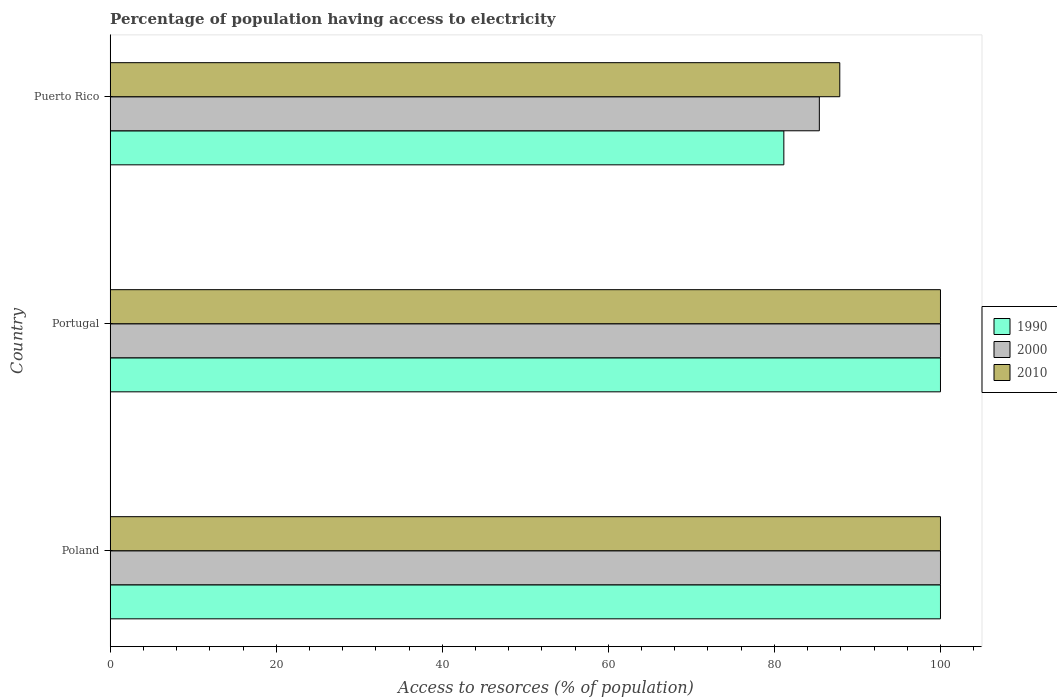How many groups of bars are there?
Provide a short and direct response. 3. Are the number of bars per tick equal to the number of legend labels?
Your answer should be compact. Yes. Are the number of bars on each tick of the Y-axis equal?
Provide a succinct answer. Yes. How many bars are there on the 1st tick from the bottom?
Your response must be concise. 3. What is the label of the 1st group of bars from the top?
Make the answer very short. Puerto Rico. Across all countries, what is the minimum percentage of population having access to electricity in 1990?
Your answer should be very brief. 81.14. In which country was the percentage of population having access to electricity in 2000 minimum?
Keep it short and to the point. Puerto Rico. What is the total percentage of population having access to electricity in 2010 in the graph?
Offer a terse response. 287.87. What is the difference between the percentage of population having access to electricity in 2000 in Portugal and that in Puerto Rico?
Ensure brevity in your answer.  14.59. What is the difference between the percentage of population having access to electricity in 1990 in Poland and the percentage of population having access to electricity in 2000 in Puerto Rico?
Offer a very short reply. 14.59. What is the average percentage of population having access to electricity in 1990 per country?
Your answer should be compact. 93.71. What is the difference between the percentage of population having access to electricity in 2010 and percentage of population having access to electricity in 2000 in Portugal?
Keep it short and to the point. 0. In how many countries, is the percentage of population having access to electricity in 2010 greater than 4 %?
Make the answer very short. 3. What is the ratio of the percentage of population having access to electricity in 1990 in Portugal to that in Puerto Rico?
Keep it short and to the point. 1.23. What is the difference between the highest and the second highest percentage of population having access to electricity in 1990?
Ensure brevity in your answer.  0. What is the difference between the highest and the lowest percentage of population having access to electricity in 2000?
Give a very brief answer. 14.59. In how many countries, is the percentage of population having access to electricity in 2000 greater than the average percentage of population having access to electricity in 2000 taken over all countries?
Your answer should be compact. 2. How many bars are there?
Give a very brief answer. 9. Are all the bars in the graph horizontal?
Keep it short and to the point. Yes. How many countries are there in the graph?
Provide a short and direct response. 3. Does the graph contain any zero values?
Keep it short and to the point. No. Where does the legend appear in the graph?
Offer a terse response. Center right. How many legend labels are there?
Offer a terse response. 3. How are the legend labels stacked?
Your answer should be compact. Vertical. What is the title of the graph?
Your answer should be compact. Percentage of population having access to electricity. Does "1998" appear as one of the legend labels in the graph?
Provide a short and direct response. No. What is the label or title of the X-axis?
Offer a terse response. Access to resorces (% of population). What is the Access to resorces (% of population) of 1990 in Poland?
Your response must be concise. 100. What is the Access to resorces (% of population) of 2010 in Poland?
Your response must be concise. 100. What is the Access to resorces (% of population) in 1990 in Portugal?
Your answer should be very brief. 100. What is the Access to resorces (% of population) in 2010 in Portugal?
Make the answer very short. 100. What is the Access to resorces (% of population) in 1990 in Puerto Rico?
Offer a terse response. 81.14. What is the Access to resorces (% of population) in 2000 in Puerto Rico?
Offer a terse response. 85.41. What is the Access to resorces (% of population) in 2010 in Puerto Rico?
Provide a short and direct response. 87.87. Across all countries, what is the maximum Access to resorces (% of population) of 2000?
Your response must be concise. 100. Across all countries, what is the minimum Access to resorces (% of population) in 1990?
Your answer should be very brief. 81.14. Across all countries, what is the minimum Access to resorces (% of population) in 2000?
Give a very brief answer. 85.41. Across all countries, what is the minimum Access to resorces (% of population) in 2010?
Offer a very short reply. 87.87. What is the total Access to resorces (% of population) of 1990 in the graph?
Your answer should be very brief. 281.14. What is the total Access to resorces (% of population) in 2000 in the graph?
Provide a succinct answer. 285.41. What is the total Access to resorces (% of population) of 2010 in the graph?
Give a very brief answer. 287.87. What is the difference between the Access to resorces (% of population) of 1990 in Poland and that in Portugal?
Your response must be concise. 0. What is the difference between the Access to resorces (% of population) of 2000 in Poland and that in Portugal?
Ensure brevity in your answer.  0. What is the difference between the Access to resorces (% of population) of 1990 in Poland and that in Puerto Rico?
Your answer should be very brief. 18.86. What is the difference between the Access to resorces (% of population) of 2000 in Poland and that in Puerto Rico?
Your answer should be very brief. 14.59. What is the difference between the Access to resorces (% of population) of 2010 in Poland and that in Puerto Rico?
Ensure brevity in your answer.  12.13. What is the difference between the Access to resorces (% of population) of 1990 in Portugal and that in Puerto Rico?
Your response must be concise. 18.86. What is the difference between the Access to resorces (% of population) of 2000 in Portugal and that in Puerto Rico?
Your answer should be compact. 14.59. What is the difference between the Access to resorces (% of population) in 2010 in Portugal and that in Puerto Rico?
Provide a succinct answer. 12.13. What is the difference between the Access to resorces (% of population) in 2000 in Poland and the Access to resorces (% of population) in 2010 in Portugal?
Your response must be concise. 0. What is the difference between the Access to resorces (% of population) of 1990 in Poland and the Access to resorces (% of population) of 2000 in Puerto Rico?
Ensure brevity in your answer.  14.59. What is the difference between the Access to resorces (% of population) of 1990 in Poland and the Access to resorces (% of population) of 2010 in Puerto Rico?
Provide a short and direct response. 12.13. What is the difference between the Access to resorces (% of population) of 2000 in Poland and the Access to resorces (% of population) of 2010 in Puerto Rico?
Give a very brief answer. 12.13. What is the difference between the Access to resorces (% of population) in 1990 in Portugal and the Access to resorces (% of population) in 2000 in Puerto Rico?
Offer a very short reply. 14.59. What is the difference between the Access to resorces (% of population) of 1990 in Portugal and the Access to resorces (% of population) of 2010 in Puerto Rico?
Ensure brevity in your answer.  12.13. What is the difference between the Access to resorces (% of population) in 2000 in Portugal and the Access to resorces (% of population) in 2010 in Puerto Rico?
Your answer should be very brief. 12.13. What is the average Access to resorces (% of population) in 1990 per country?
Your answer should be very brief. 93.71. What is the average Access to resorces (% of population) of 2000 per country?
Keep it short and to the point. 95.14. What is the average Access to resorces (% of population) in 2010 per country?
Keep it short and to the point. 95.96. What is the difference between the Access to resorces (% of population) in 2000 and Access to resorces (% of population) in 2010 in Poland?
Provide a short and direct response. 0. What is the difference between the Access to resorces (% of population) of 1990 and Access to resorces (% of population) of 2000 in Portugal?
Offer a terse response. 0. What is the difference between the Access to resorces (% of population) of 2000 and Access to resorces (% of population) of 2010 in Portugal?
Keep it short and to the point. 0. What is the difference between the Access to resorces (% of population) of 1990 and Access to resorces (% of population) of 2000 in Puerto Rico?
Offer a terse response. -4.28. What is the difference between the Access to resorces (% of population) of 1990 and Access to resorces (% of population) of 2010 in Puerto Rico?
Offer a very short reply. -6.74. What is the difference between the Access to resorces (% of population) of 2000 and Access to resorces (% of population) of 2010 in Puerto Rico?
Provide a succinct answer. -2.46. What is the ratio of the Access to resorces (% of population) in 1990 in Poland to that in Portugal?
Offer a very short reply. 1. What is the ratio of the Access to resorces (% of population) of 2000 in Poland to that in Portugal?
Your answer should be very brief. 1. What is the ratio of the Access to resorces (% of population) in 2010 in Poland to that in Portugal?
Your answer should be compact. 1. What is the ratio of the Access to resorces (% of population) in 1990 in Poland to that in Puerto Rico?
Make the answer very short. 1.23. What is the ratio of the Access to resorces (% of population) in 2000 in Poland to that in Puerto Rico?
Provide a short and direct response. 1.17. What is the ratio of the Access to resorces (% of population) of 2010 in Poland to that in Puerto Rico?
Your answer should be compact. 1.14. What is the ratio of the Access to resorces (% of population) in 1990 in Portugal to that in Puerto Rico?
Offer a very short reply. 1.23. What is the ratio of the Access to resorces (% of population) in 2000 in Portugal to that in Puerto Rico?
Keep it short and to the point. 1.17. What is the ratio of the Access to resorces (% of population) of 2010 in Portugal to that in Puerto Rico?
Make the answer very short. 1.14. What is the difference between the highest and the lowest Access to resorces (% of population) of 1990?
Provide a succinct answer. 18.86. What is the difference between the highest and the lowest Access to resorces (% of population) in 2000?
Ensure brevity in your answer.  14.59. What is the difference between the highest and the lowest Access to resorces (% of population) in 2010?
Ensure brevity in your answer.  12.13. 